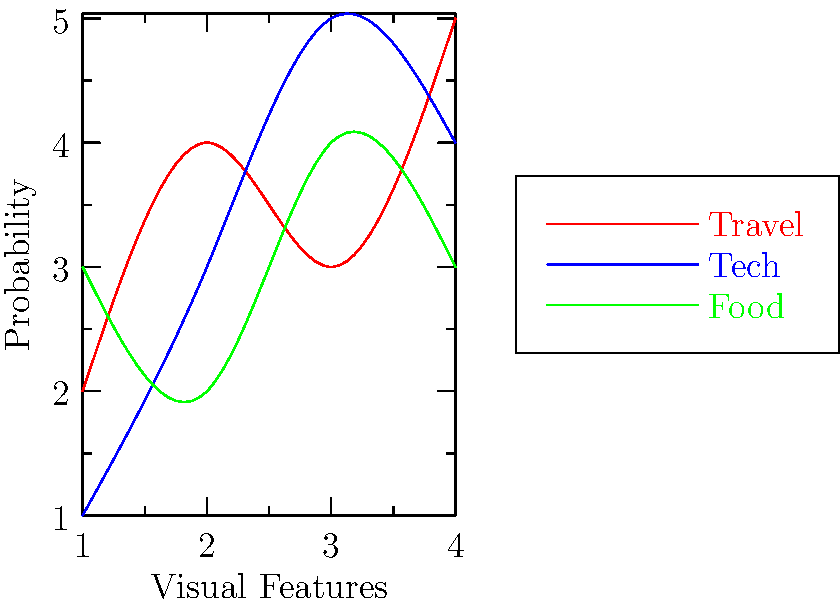Given the graph showing the probability distribution of visual features for different blog post types, which classification algorithm would be most suitable for distinguishing between travel, tech, and food blog posts based on their visual characteristics? To determine the most suitable classification algorithm, we need to analyze the graph and consider the nature of the problem:

1. The graph shows three distinct curves representing travel, tech, and food blog posts.
2. These curves have overlapping regions, indicating some similarity in visual features across categories.
3. The relationships between visual features and blog post types appear to be non-linear.
4. We are dealing with multiple classes (travel, tech, food).
5. The problem involves classifying images based on visual features, which typically have high dimensionality.

Considering these factors:

a) Linear classifiers (e.g., Logistic Regression) might not perform well due to the non-linear nature of the data.
b) Support Vector Machines (SVM) with non-linear kernels could handle the complexity but may struggle with multi-class problems.
c) Decision Trees or Random Forests could work but might not capture the nuanced relationships in high-dimensional image data.
d) Neural Networks, particularly Convolutional Neural Networks (CNNs), are well-suited for image classification tasks with multiple classes and complex, non-linear relationships.

CNNs are designed to automatically learn hierarchical features from image data, making them ideal for this scenario. They can handle the high dimensionality of image data and learn intricate patterns that distinguish between different blog post types based on visual characteristics.
Answer: Convolutional Neural Network (CNN) 